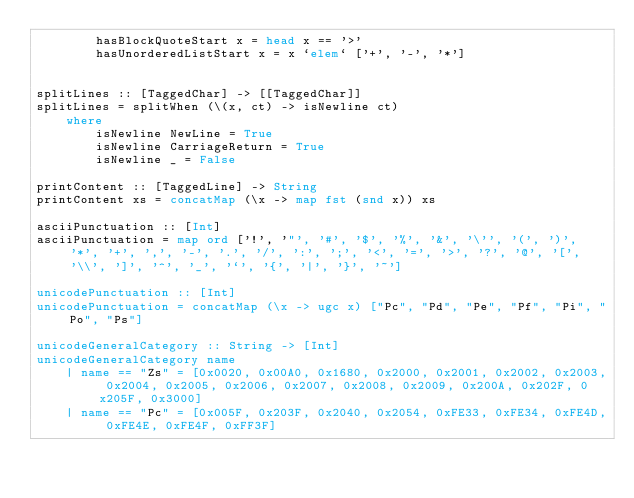<code> <loc_0><loc_0><loc_500><loc_500><_Haskell_>        hasBlockQuoteStart x = head x == '>'
        hasUnorderedListStart x = x `elem` ['+', '-', '*']


splitLines :: [TaggedChar] -> [[TaggedChar]]
splitLines = splitWhen (\(x, ct) -> isNewline ct)
    where
        isNewline NewLine = True
        isNewline CarriageReturn = True
        isNewline _ = False

printContent :: [TaggedLine] -> String
printContent xs = concatMap (\x -> map fst (snd x)) xs

asciiPunctuation :: [Int]
asciiPunctuation = map ord ['!', '"', '#', '$', '%', '&', '\'', '(', ')', '*', '+', ',', '-', '.', '/', ':', ';', '<', '=', '>', '?', '@', '[', '\\', ']', '^', '_', '`', '{', '|', '}', '~']

unicodePunctuation :: [Int]
unicodePunctuation = concatMap (\x -> ugc x) ["Pc", "Pd", "Pe", "Pf", "Pi", "Po", "Ps"]

unicodeGeneralCategory :: String -> [Int]
unicodeGeneralCategory name
    | name == "Zs" = [0x0020, 0x00A0, 0x1680, 0x2000, 0x2001, 0x2002, 0x2003, 0x2004, 0x2005, 0x2006, 0x2007, 0x2008, 0x2009, 0x200A, 0x202F, 0x205F, 0x3000]
    | name == "Pc" = [0x005F, 0x203F, 0x2040, 0x2054, 0xFE33, 0xFE34, 0xFE4D, 0xFE4E, 0xFE4F, 0xFF3F]</code> 